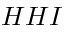<formula> <loc_0><loc_0><loc_500><loc_500>H H I</formula> 